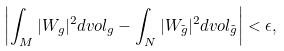Convert formula to latex. <formula><loc_0><loc_0><loc_500><loc_500>& \left | \int _ { M } | W _ { g } | ^ { 2 } d v o l _ { g } - \int _ { N } | W _ { \tilde { g } } | ^ { 2 } d v o l _ { \tilde { g } } \right | < \epsilon ,</formula> 